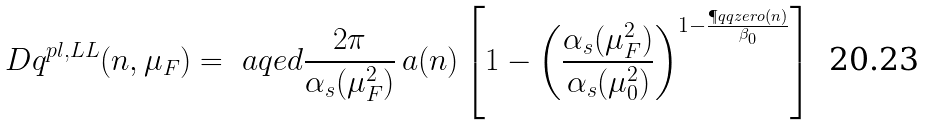Convert formula to latex. <formula><loc_0><loc_0><loc_500><loc_500>\ D q ^ { p l , L L } ( n , \mu _ { F } ) = \ a q e d \frac { 2 \pi } { \alpha _ { s } ( \mu _ { F } ^ { 2 } ) } \, a ( n ) \left [ 1 - \left ( \frac { \alpha _ { s } ( \mu _ { F } ^ { 2 } ) } { \alpha _ { s } ( \mu _ { 0 } ^ { 2 } ) } \right ) ^ { 1 - \frac { \P q q z e r o ( n ) } { \beta _ { 0 } } } \right ]</formula> 